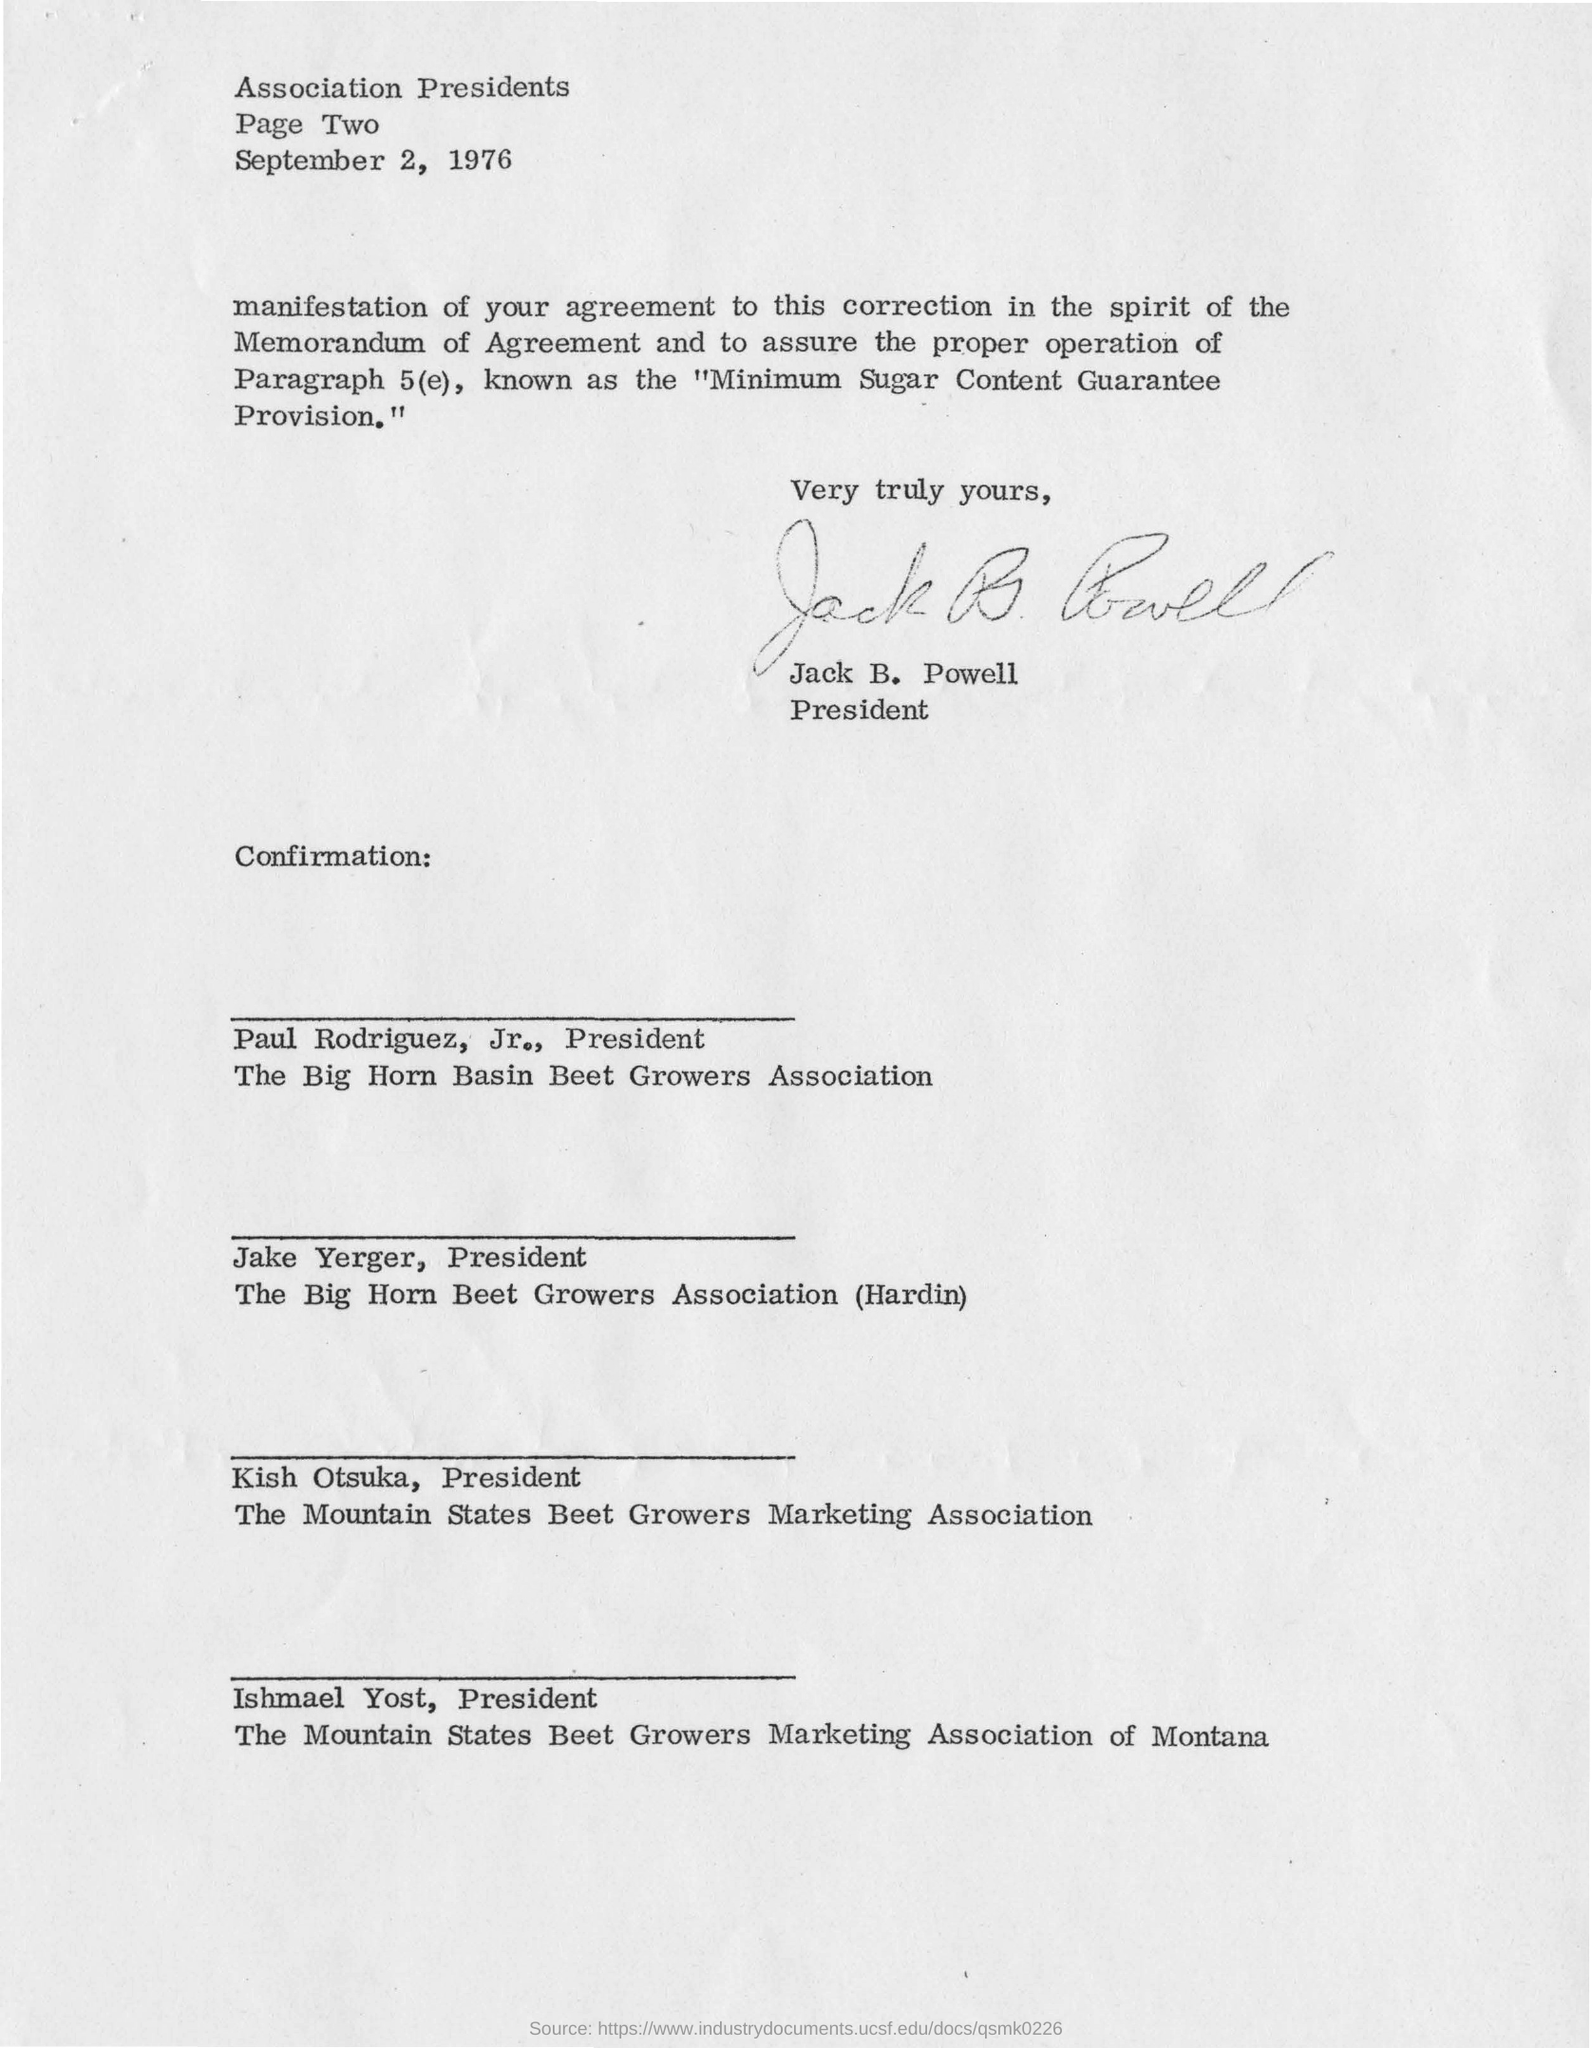Outline some significant characteristics in this image. The letter is from Jack B. Powell. 